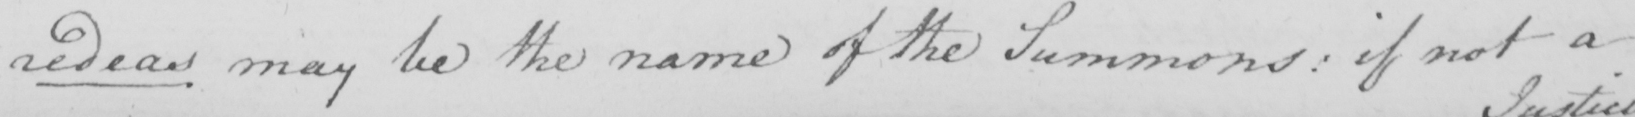What does this handwritten line say? sedeas may be the name of the Summons :  if not a 